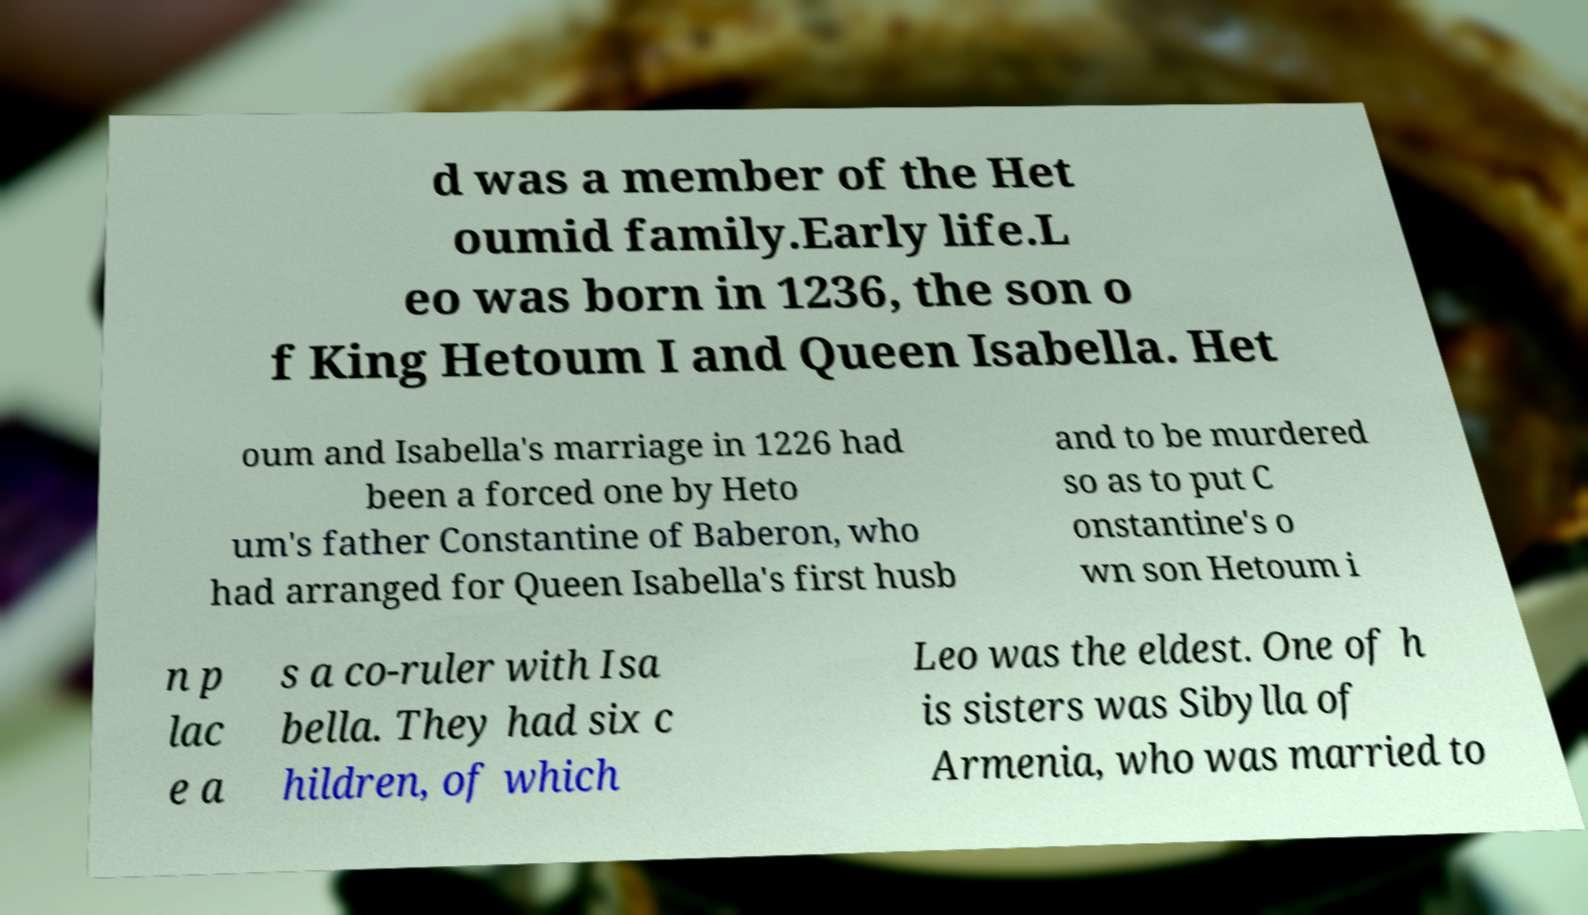For documentation purposes, I need the text within this image transcribed. Could you provide that? d was a member of the Het oumid family.Early life.L eo was born in 1236, the son o f King Hetoum I and Queen Isabella. Het oum and Isabella's marriage in 1226 had been a forced one by Heto um's father Constantine of Baberon, who had arranged for Queen Isabella's first husb and to be murdered so as to put C onstantine's o wn son Hetoum i n p lac e a s a co-ruler with Isa bella. They had six c hildren, of which Leo was the eldest. One of h is sisters was Sibylla of Armenia, who was married to 